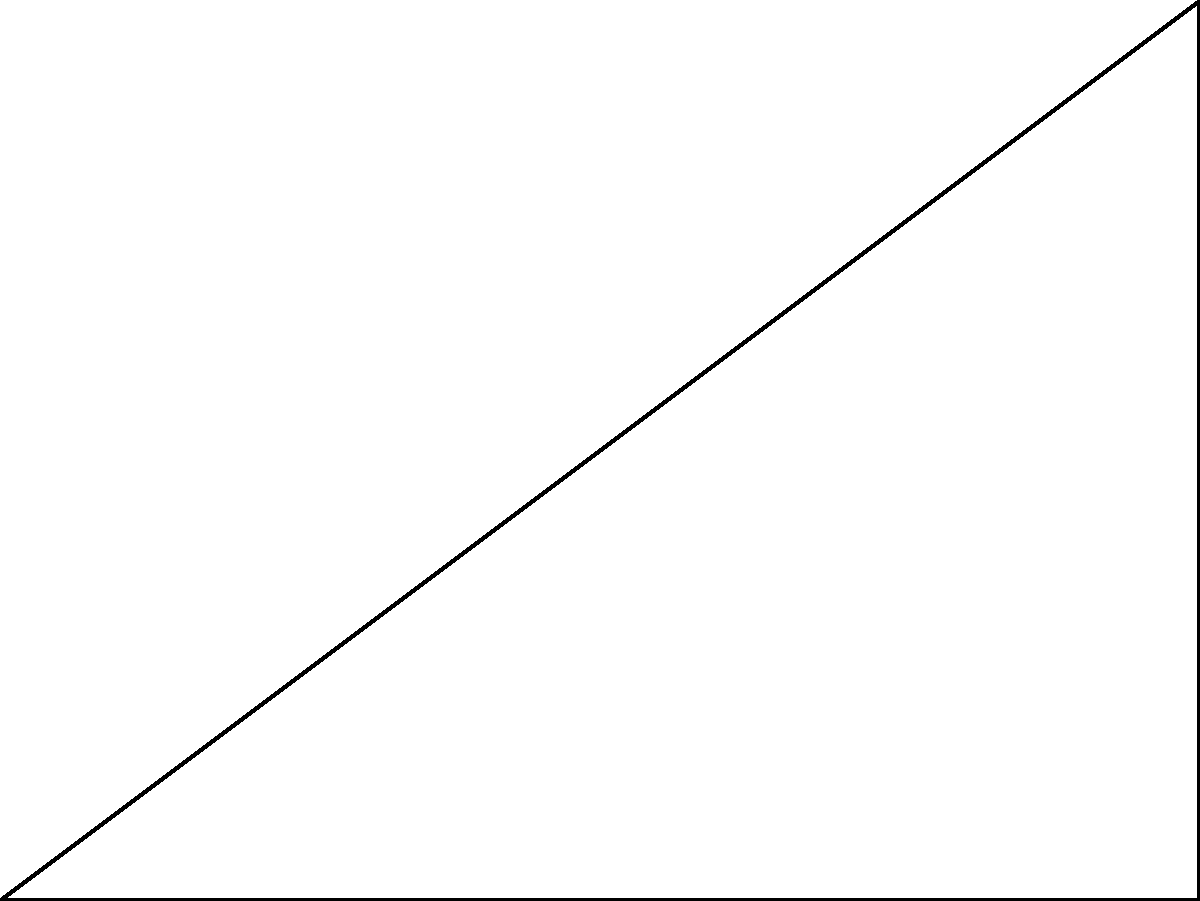As part of your conservation education program, you're explaining the importance of renewable energy to students. You're discussing solar panels and their optimal positioning. A rectangular solar panel with a width of 4 meters is installed on a roof. To receive maximum sunlight, it needs to be tilted at an angle of 30° from the horizontal. What height $h$ should the upper edge of the panel be raised to achieve this optimal angle? Let's approach this step-by-step:

1) In the diagram, we have a right-angled triangle OAB, where:
   - OA is the width of the solar panel (4 meters)
   - AB is the height we need to find ($h$)
   - Angle BAO is the optimal angle (30°)

2) We can use the tangent trigonometric function to solve this problem. The tangent of an angle in a right triangle is the ratio of the opposite side to the adjacent side.

3) In this case:
   $\tan(\theta) = \frac{\text{opposite}}{\text{adjacent}} = \frac{h}{w}$

4) We know that $\theta = 30°$ and $w = 4$ meters. Let's substitute these values:

   $\tan(30°) = \frac{h}{4}$

5) We know that $\tan(30°) = \frac{1}{\sqrt{3}}$. Let's substitute this:

   $\frac{1}{\sqrt{3}} = \frac{h}{4}$

6) Now, let's solve for $h$:
   
   $h = 4 \cdot \frac{1}{\sqrt{3}}$

7) Simplify:
   
   $h = \frac{4}{\sqrt{3}} = \frac{4\sqrt{3}}{3} \approx 2.31$ meters

Therefore, the upper edge of the solar panel should be raised approximately 2.31 meters to achieve the optimal angle of 30°.
Answer: $\frac{4\sqrt{3}}{3}$ meters (or approximately 2.31 meters) 